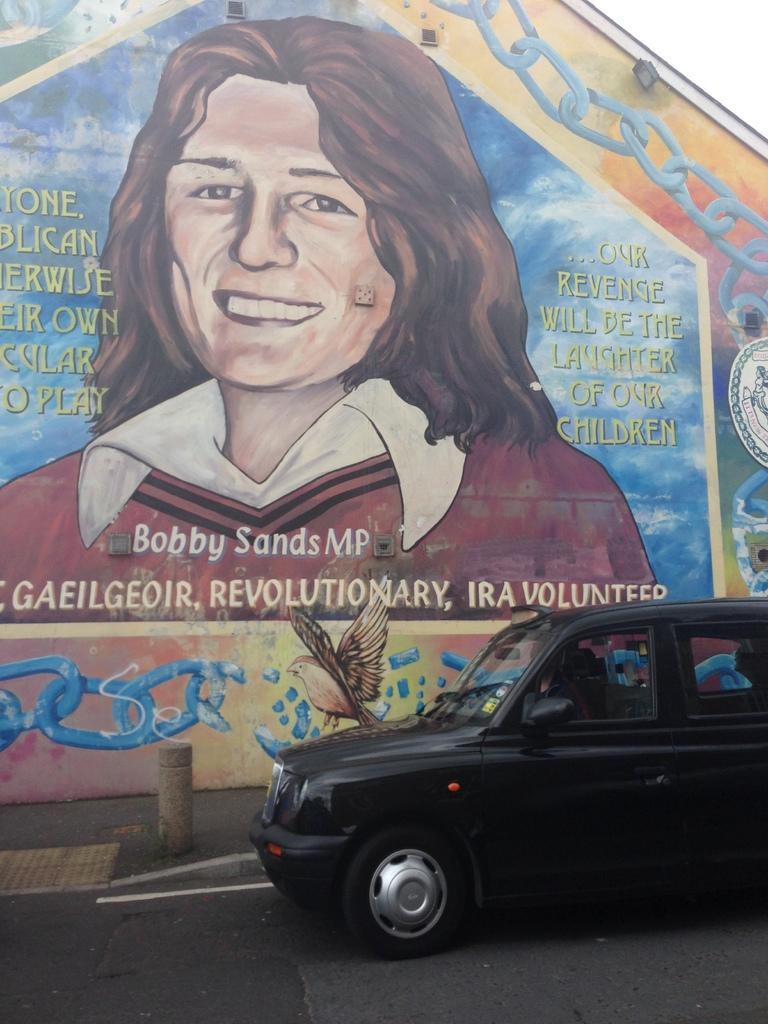What is the main feature of the image? There is a road in the image. What is on the road? There is a car on the road. What can be seen in the background of the image? There is a wall in the background of the image. What is depicted on the wall? There is a painting of a woman on the wall. What else is present on the wall? There is text written on the wall. What type of silk is being used to cover the rail in the image? There is no rail or silk present in the image. What is the front of the car facing in the image? The provided facts do not mention the direction the car is facing, so it cannot be determined from the image. 